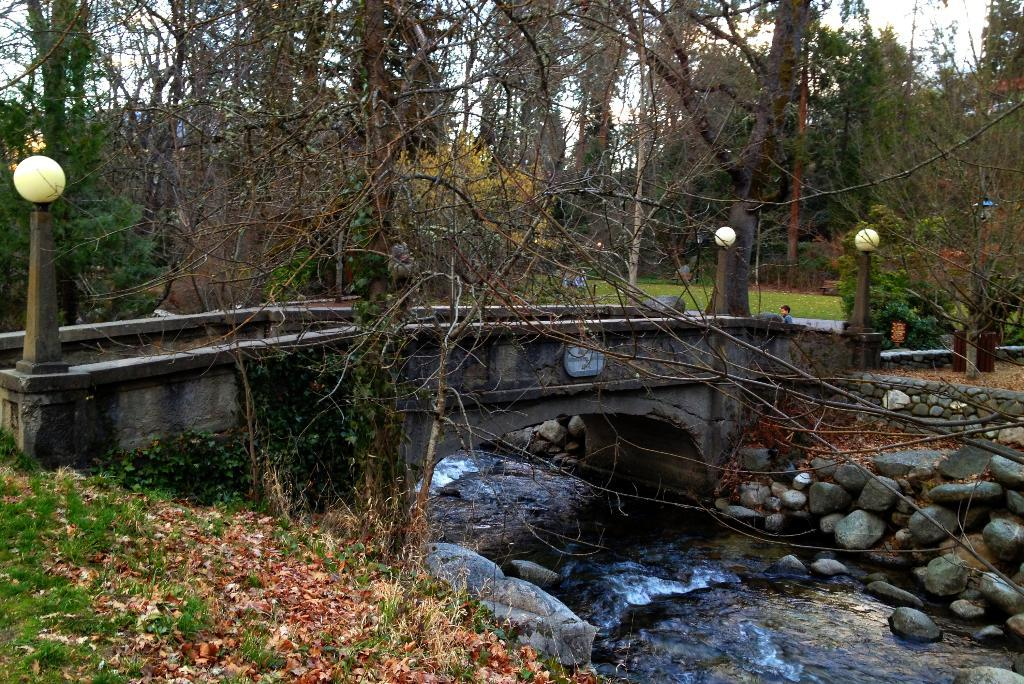What is located in the foreground of the image? There are stones, a bridge, water, and lamp poles in the foreground of the image. What can be seen in the background of the image? There are trees, grassland, and the sky visible in the background of the image. What type of vegetation is present in the background? There are trees in the background of the image. What type of terrain is visible in the background? There is grassland visible in the background of the image. How many minutes does it take for the rabbit to cross the bridge in the image? There is no rabbit present in the image, so it is not possible to determine how long it would take for a rabbit to cross the bridge. 